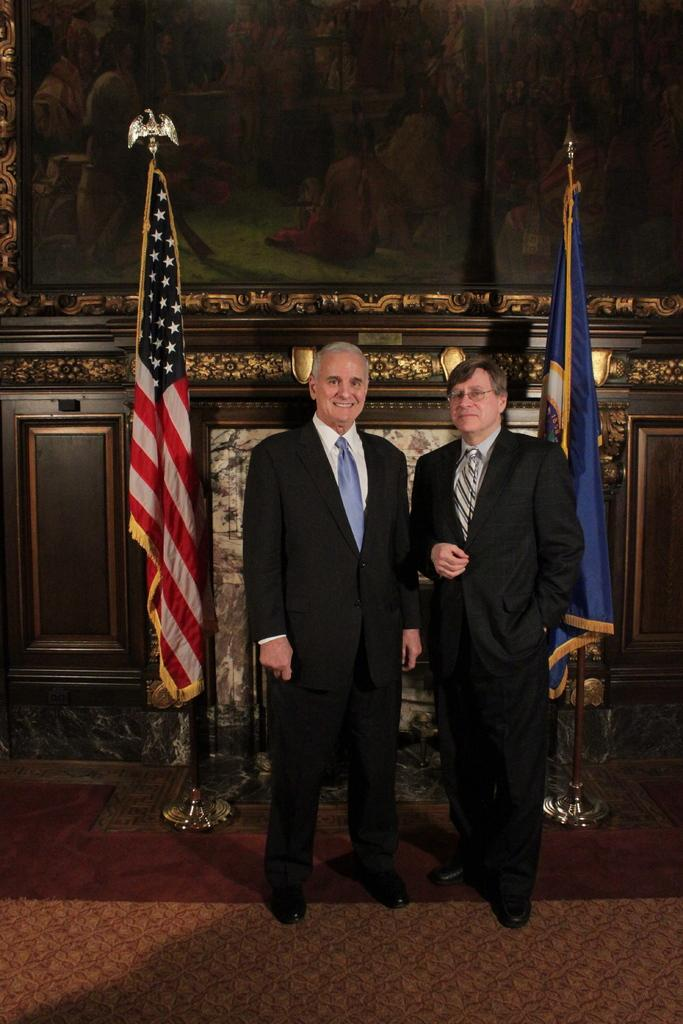How many people are in the image? There are two men standing in the image. What can be seen behind the men? There are poles with flags behind the men. What is on the wall in the image? There is a wall with a frame in the image. What kind of decorations are on the wall? There are designs on the wall. How does the hand exchange increase the value of the frame in the image? There is no hand or exchange present in the image, and the value of the frame is not mentioned. 